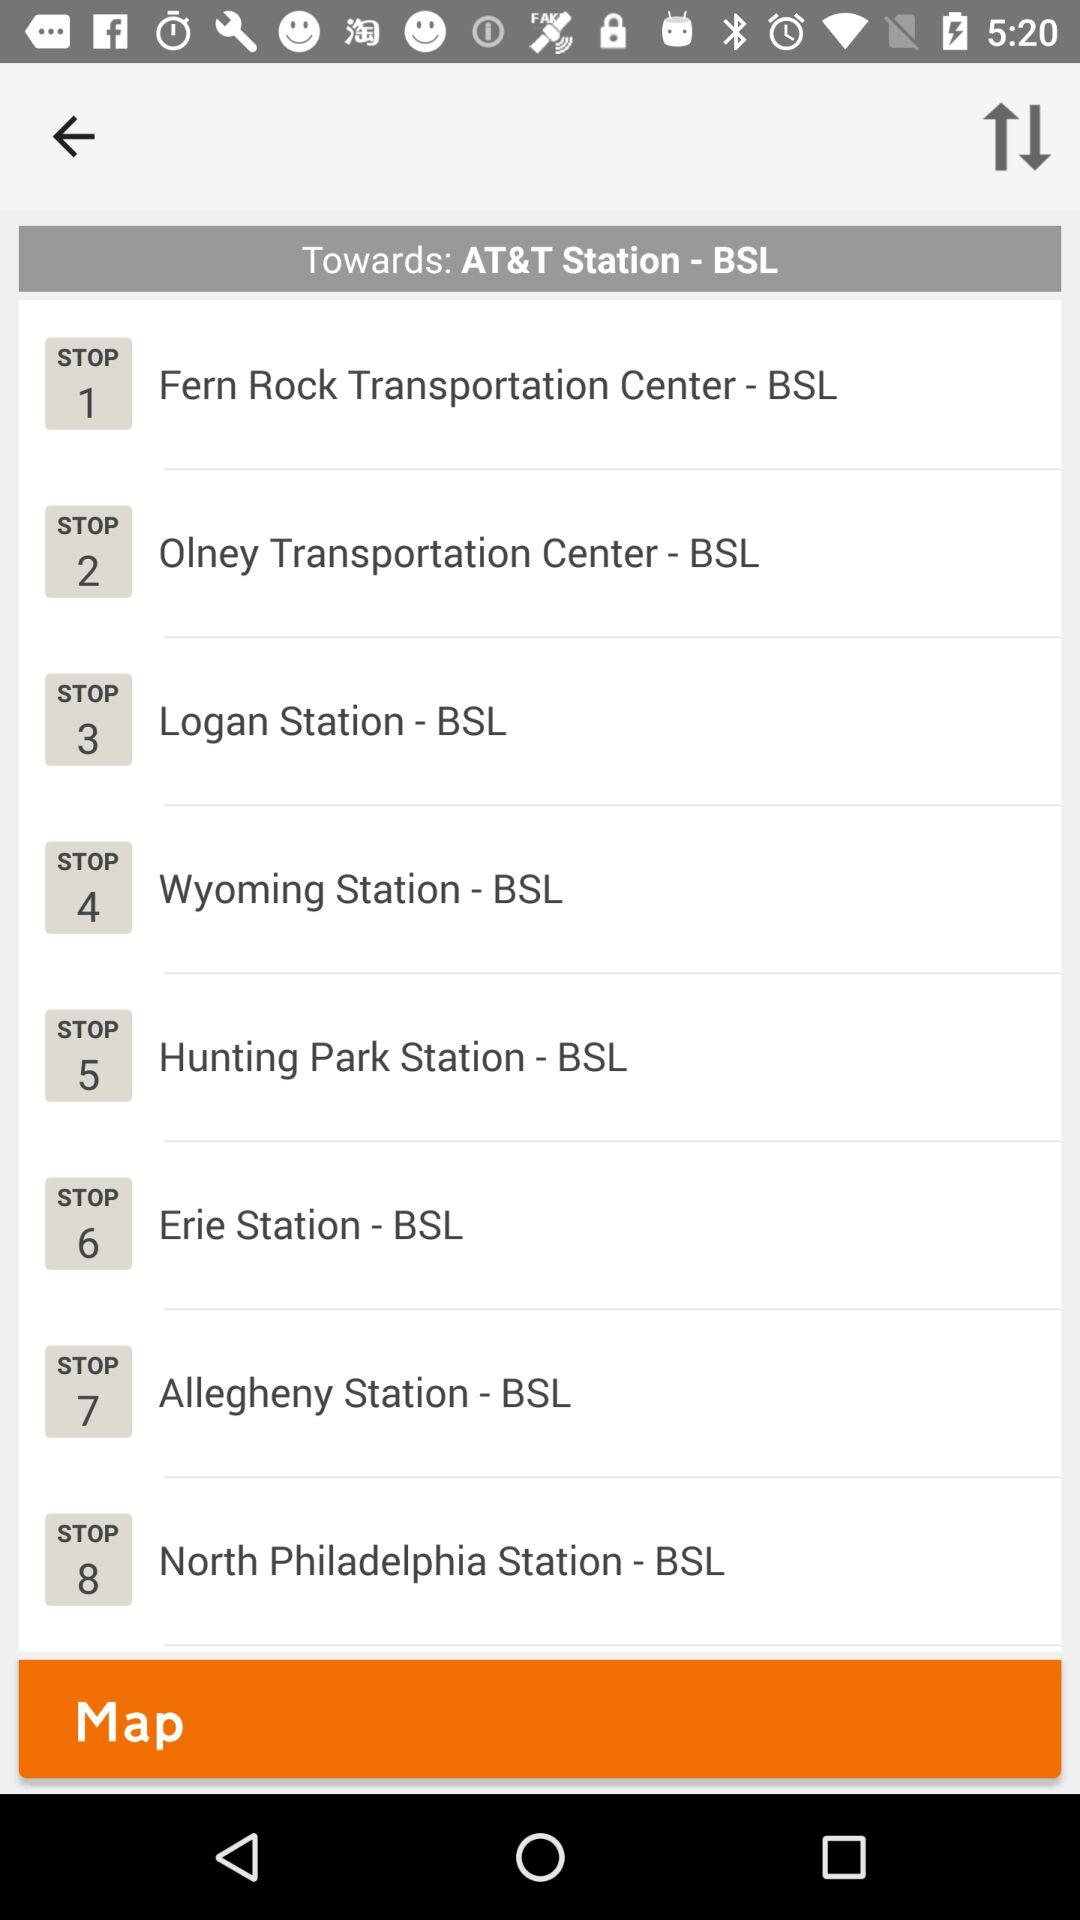What's the "Erie Station - BSL" stop number? The stop number is 6. 